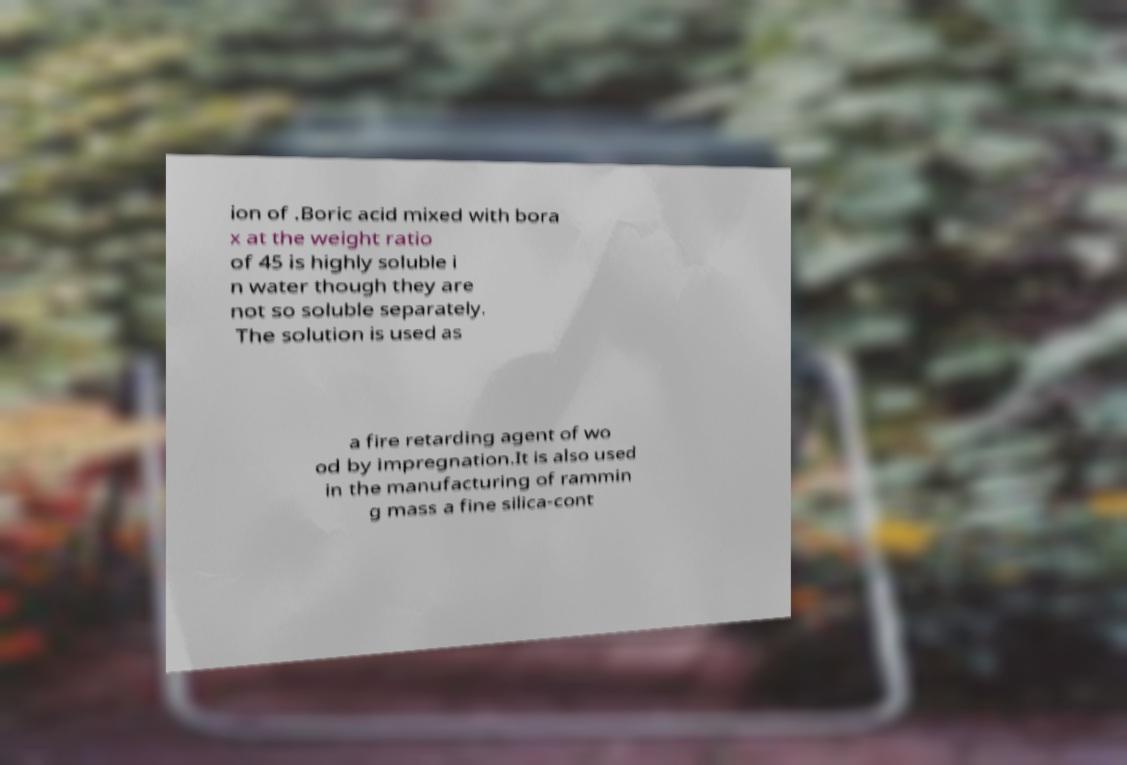Can you read and provide the text displayed in the image?This photo seems to have some interesting text. Can you extract and type it out for me? ion of .Boric acid mixed with bora x at the weight ratio of 45 is highly soluble i n water though they are not so soluble separately. The solution is used as a fire retarding agent of wo od by impregnation.It is also used in the manufacturing of rammin g mass a fine silica-cont 